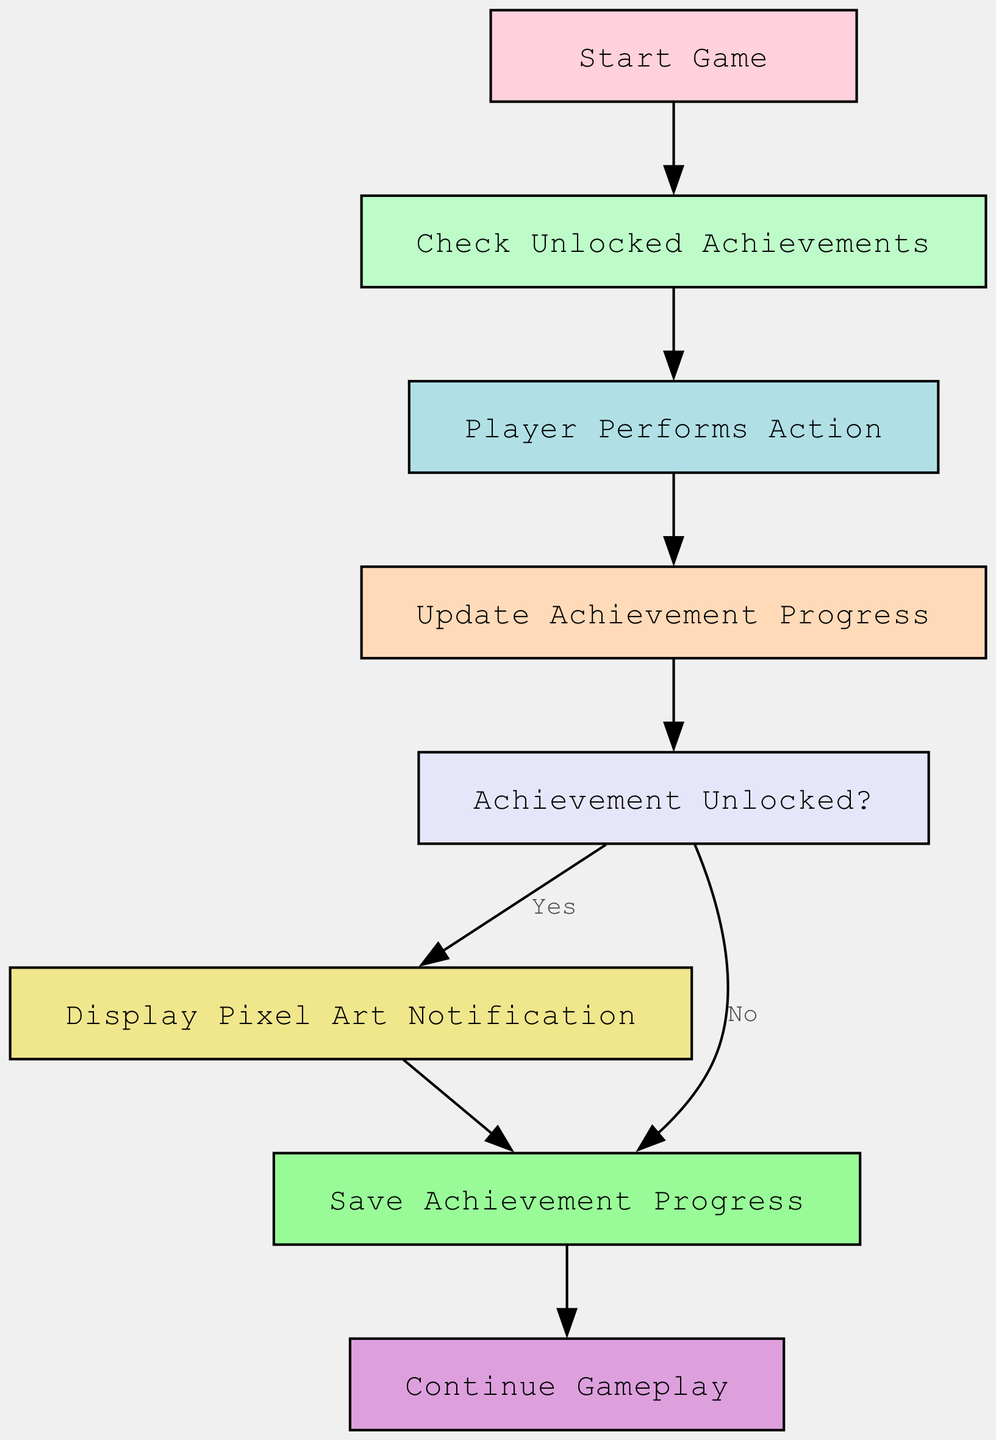What is the first node in the flowchart? The first node is labeled "Start Game," which indicates the beginning of the achievement system process.
Answer: Start Game How many edges are in the flowchart? By counting the lines connecting the nodes, we find that there are seven edges leading from one node to another.
Answer: 7 What does the node "update progress" represent in the flowchart? The "update progress" node signifies the step where the achievement progress is updated after the player performs an action.
Answer: Update Achievement Progress Which node follows "display notification"? The node that follows "display notification" is "save progress," indicating that after a notification is displayed, the achievement progress is saved.
Answer: Save Achievement Progress What is the decision point in the diagram? The decision point is the "Achievement Unlocked?" node, where the flow diverges based on whether an achievement has been unlocked or not.
Answer: Achievement Unlocked? What happens if the achievement is unlocked? If the achievement is unlocked, the flow goes to "display notification" to inform the player about their achievement.
Answer: Display Pixel Art Notification How many nodes are part of the flowchart? There are eight distinct nodes in the flowchart detailing different parts of the achievement system process.
Answer: 8 Which node represents the end of the achievement process? The node labeled "Continue Gameplay" represents the end of the achievement process, indicating that the game continues after saving progress.
Answer: Continue Gameplay What action is taken after the player performs an action? After the player performs an action, the "update progress" node is executed to update the achievement progress accordingly.
Answer: Update Achievement Progress 